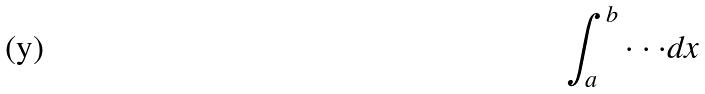<formula> <loc_0><loc_0><loc_500><loc_500>\int _ { a } ^ { b } \cdot \cdot \cdot d x</formula> 